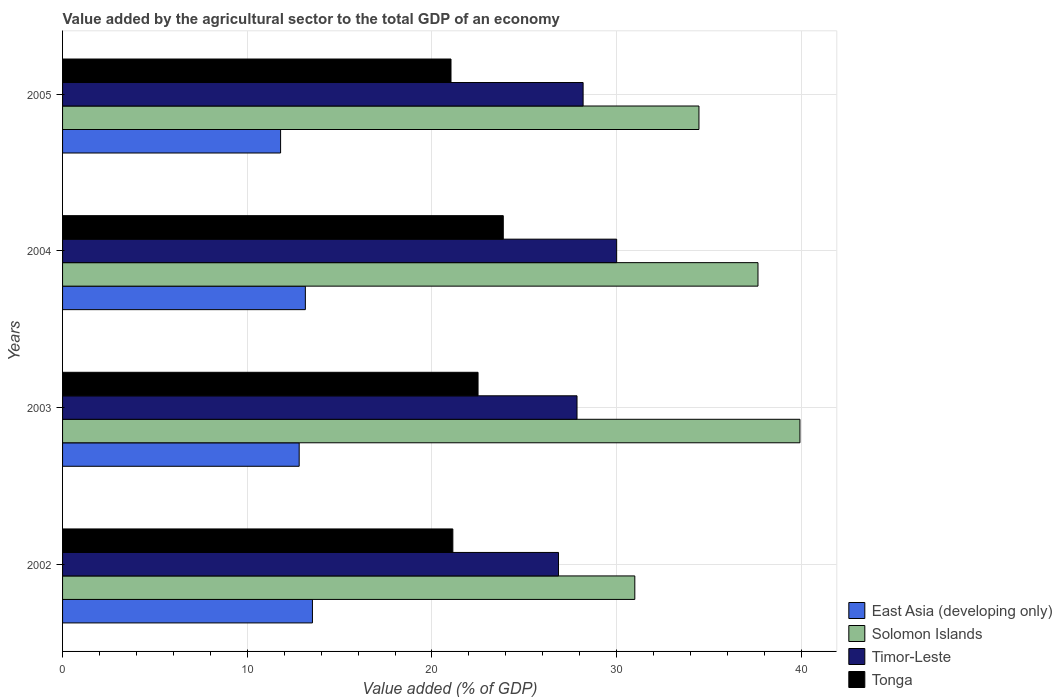How many groups of bars are there?
Make the answer very short. 4. Are the number of bars per tick equal to the number of legend labels?
Your response must be concise. Yes. Are the number of bars on each tick of the Y-axis equal?
Provide a short and direct response. Yes. How many bars are there on the 3rd tick from the bottom?
Make the answer very short. 4. What is the value added by the agricultural sector to the total GDP in Timor-Leste in 2005?
Provide a short and direct response. 28.18. Across all years, what is the maximum value added by the agricultural sector to the total GDP in Tonga?
Keep it short and to the point. 23.86. Across all years, what is the minimum value added by the agricultural sector to the total GDP in Tonga?
Your response must be concise. 21.03. In which year was the value added by the agricultural sector to the total GDP in Solomon Islands maximum?
Offer a very short reply. 2003. In which year was the value added by the agricultural sector to the total GDP in Timor-Leste minimum?
Ensure brevity in your answer.  2002. What is the total value added by the agricultural sector to the total GDP in Tonga in the graph?
Your response must be concise. 88.52. What is the difference between the value added by the agricultural sector to the total GDP in East Asia (developing only) in 2004 and that in 2005?
Your answer should be compact. 1.34. What is the difference between the value added by the agricultural sector to the total GDP in Tonga in 2005 and the value added by the agricultural sector to the total GDP in Timor-Leste in 2002?
Offer a terse response. -5.82. What is the average value added by the agricultural sector to the total GDP in Tonga per year?
Ensure brevity in your answer.  22.13. In the year 2004, what is the difference between the value added by the agricultural sector to the total GDP in Solomon Islands and value added by the agricultural sector to the total GDP in East Asia (developing only)?
Provide a succinct answer. 24.51. In how many years, is the value added by the agricultural sector to the total GDP in East Asia (developing only) greater than 18 %?
Your answer should be very brief. 0. What is the ratio of the value added by the agricultural sector to the total GDP in Tonga in 2002 to that in 2003?
Provide a short and direct response. 0.94. What is the difference between the highest and the second highest value added by the agricultural sector to the total GDP in Solomon Islands?
Make the answer very short. 2.27. What is the difference between the highest and the lowest value added by the agricultural sector to the total GDP in Timor-Leste?
Your answer should be compact. 3.15. In how many years, is the value added by the agricultural sector to the total GDP in Tonga greater than the average value added by the agricultural sector to the total GDP in Tonga taken over all years?
Provide a succinct answer. 2. What does the 4th bar from the top in 2002 represents?
Offer a very short reply. East Asia (developing only). What does the 1st bar from the bottom in 2004 represents?
Provide a succinct answer. East Asia (developing only). Is it the case that in every year, the sum of the value added by the agricultural sector to the total GDP in Tonga and value added by the agricultural sector to the total GDP in Timor-Leste is greater than the value added by the agricultural sector to the total GDP in Solomon Islands?
Offer a very short reply. Yes. How many bars are there?
Provide a succinct answer. 16. Are the values on the major ticks of X-axis written in scientific E-notation?
Keep it short and to the point. No. Does the graph contain any zero values?
Provide a succinct answer. No. Does the graph contain grids?
Provide a succinct answer. Yes. Where does the legend appear in the graph?
Provide a succinct answer. Bottom right. How many legend labels are there?
Your answer should be very brief. 4. What is the title of the graph?
Offer a terse response. Value added by the agricultural sector to the total GDP of an economy. Does "Monaco" appear as one of the legend labels in the graph?
Provide a succinct answer. No. What is the label or title of the X-axis?
Give a very brief answer. Value added (% of GDP). What is the label or title of the Y-axis?
Your answer should be compact. Years. What is the Value added (% of GDP) of East Asia (developing only) in 2002?
Keep it short and to the point. 13.53. What is the Value added (% of GDP) of Solomon Islands in 2002?
Make the answer very short. 30.98. What is the Value added (% of GDP) of Timor-Leste in 2002?
Give a very brief answer. 26.85. What is the Value added (% of GDP) of Tonga in 2002?
Make the answer very short. 21.13. What is the Value added (% of GDP) of East Asia (developing only) in 2003?
Your answer should be very brief. 12.81. What is the Value added (% of GDP) of Solomon Islands in 2003?
Your answer should be very brief. 39.92. What is the Value added (% of GDP) of Timor-Leste in 2003?
Offer a very short reply. 27.85. What is the Value added (% of GDP) in Tonga in 2003?
Give a very brief answer. 22.5. What is the Value added (% of GDP) in East Asia (developing only) in 2004?
Provide a short and direct response. 13.15. What is the Value added (% of GDP) of Solomon Islands in 2004?
Provide a succinct answer. 37.65. What is the Value added (% of GDP) of Timor-Leste in 2004?
Make the answer very short. 30. What is the Value added (% of GDP) of Tonga in 2004?
Give a very brief answer. 23.86. What is the Value added (% of GDP) in East Asia (developing only) in 2005?
Give a very brief answer. 11.8. What is the Value added (% of GDP) of Solomon Islands in 2005?
Offer a terse response. 34.46. What is the Value added (% of GDP) of Timor-Leste in 2005?
Ensure brevity in your answer.  28.18. What is the Value added (% of GDP) of Tonga in 2005?
Offer a terse response. 21.03. Across all years, what is the maximum Value added (% of GDP) of East Asia (developing only)?
Your response must be concise. 13.53. Across all years, what is the maximum Value added (% of GDP) of Solomon Islands?
Give a very brief answer. 39.92. Across all years, what is the maximum Value added (% of GDP) in Timor-Leste?
Provide a succinct answer. 30. Across all years, what is the maximum Value added (% of GDP) in Tonga?
Your answer should be very brief. 23.86. Across all years, what is the minimum Value added (% of GDP) in East Asia (developing only)?
Ensure brevity in your answer.  11.8. Across all years, what is the minimum Value added (% of GDP) of Solomon Islands?
Your answer should be very brief. 30.98. Across all years, what is the minimum Value added (% of GDP) in Timor-Leste?
Provide a succinct answer. 26.85. Across all years, what is the minimum Value added (% of GDP) in Tonga?
Offer a terse response. 21.03. What is the total Value added (% of GDP) in East Asia (developing only) in the graph?
Give a very brief answer. 51.29. What is the total Value added (% of GDP) of Solomon Islands in the graph?
Provide a succinct answer. 143.01. What is the total Value added (% of GDP) of Timor-Leste in the graph?
Your answer should be very brief. 112.89. What is the total Value added (% of GDP) of Tonga in the graph?
Your answer should be compact. 88.52. What is the difference between the Value added (% of GDP) in East Asia (developing only) in 2002 and that in 2003?
Offer a very short reply. 0.72. What is the difference between the Value added (% of GDP) in Solomon Islands in 2002 and that in 2003?
Make the answer very short. -8.94. What is the difference between the Value added (% of GDP) of Timor-Leste in 2002 and that in 2003?
Your response must be concise. -1. What is the difference between the Value added (% of GDP) in Tonga in 2002 and that in 2003?
Provide a short and direct response. -1.36. What is the difference between the Value added (% of GDP) in East Asia (developing only) in 2002 and that in 2004?
Your response must be concise. 0.38. What is the difference between the Value added (% of GDP) of Solomon Islands in 2002 and that in 2004?
Your answer should be compact. -6.67. What is the difference between the Value added (% of GDP) in Timor-Leste in 2002 and that in 2004?
Your response must be concise. -3.15. What is the difference between the Value added (% of GDP) of Tonga in 2002 and that in 2004?
Give a very brief answer. -2.73. What is the difference between the Value added (% of GDP) in East Asia (developing only) in 2002 and that in 2005?
Your answer should be very brief. 1.72. What is the difference between the Value added (% of GDP) of Solomon Islands in 2002 and that in 2005?
Provide a short and direct response. -3.47. What is the difference between the Value added (% of GDP) in Timor-Leste in 2002 and that in 2005?
Give a very brief answer. -1.33. What is the difference between the Value added (% of GDP) in Tonga in 2002 and that in 2005?
Ensure brevity in your answer.  0.1. What is the difference between the Value added (% of GDP) in East Asia (developing only) in 2003 and that in 2004?
Keep it short and to the point. -0.33. What is the difference between the Value added (% of GDP) of Solomon Islands in 2003 and that in 2004?
Your answer should be very brief. 2.27. What is the difference between the Value added (% of GDP) of Timor-Leste in 2003 and that in 2004?
Provide a short and direct response. -2.15. What is the difference between the Value added (% of GDP) of Tonga in 2003 and that in 2004?
Give a very brief answer. -1.37. What is the difference between the Value added (% of GDP) of Solomon Islands in 2003 and that in 2005?
Provide a succinct answer. 5.47. What is the difference between the Value added (% of GDP) in Timor-Leste in 2003 and that in 2005?
Your response must be concise. -0.33. What is the difference between the Value added (% of GDP) in Tonga in 2003 and that in 2005?
Offer a terse response. 1.46. What is the difference between the Value added (% of GDP) in East Asia (developing only) in 2004 and that in 2005?
Provide a short and direct response. 1.34. What is the difference between the Value added (% of GDP) of Solomon Islands in 2004 and that in 2005?
Your answer should be very brief. 3.2. What is the difference between the Value added (% of GDP) of Timor-Leste in 2004 and that in 2005?
Give a very brief answer. 1.82. What is the difference between the Value added (% of GDP) in Tonga in 2004 and that in 2005?
Keep it short and to the point. 2.83. What is the difference between the Value added (% of GDP) of East Asia (developing only) in 2002 and the Value added (% of GDP) of Solomon Islands in 2003?
Give a very brief answer. -26.39. What is the difference between the Value added (% of GDP) in East Asia (developing only) in 2002 and the Value added (% of GDP) in Timor-Leste in 2003?
Provide a short and direct response. -14.32. What is the difference between the Value added (% of GDP) in East Asia (developing only) in 2002 and the Value added (% of GDP) in Tonga in 2003?
Keep it short and to the point. -8.97. What is the difference between the Value added (% of GDP) in Solomon Islands in 2002 and the Value added (% of GDP) in Timor-Leste in 2003?
Your answer should be compact. 3.13. What is the difference between the Value added (% of GDP) in Solomon Islands in 2002 and the Value added (% of GDP) in Tonga in 2003?
Ensure brevity in your answer.  8.49. What is the difference between the Value added (% of GDP) in Timor-Leste in 2002 and the Value added (% of GDP) in Tonga in 2003?
Ensure brevity in your answer.  4.36. What is the difference between the Value added (% of GDP) of East Asia (developing only) in 2002 and the Value added (% of GDP) of Solomon Islands in 2004?
Offer a terse response. -24.12. What is the difference between the Value added (% of GDP) of East Asia (developing only) in 2002 and the Value added (% of GDP) of Timor-Leste in 2004?
Ensure brevity in your answer.  -16.47. What is the difference between the Value added (% of GDP) in East Asia (developing only) in 2002 and the Value added (% of GDP) in Tonga in 2004?
Your answer should be compact. -10.33. What is the difference between the Value added (% of GDP) in Solomon Islands in 2002 and the Value added (% of GDP) in Timor-Leste in 2004?
Keep it short and to the point. 0.98. What is the difference between the Value added (% of GDP) of Solomon Islands in 2002 and the Value added (% of GDP) of Tonga in 2004?
Your answer should be very brief. 7.12. What is the difference between the Value added (% of GDP) of Timor-Leste in 2002 and the Value added (% of GDP) of Tonga in 2004?
Keep it short and to the point. 2.99. What is the difference between the Value added (% of GDP) of East Asia (developing only) in 2002 and the Value added (% of GDP) of Solomon Islands in 2005?
Your answer should be very brief. -20.93. What is the difference between the Value added (% of GDP) in East Asia (developing only) in 2002 and the Value added (% of GDP) in Timor-Leste in 2005?
Offer a very short reply. -14.65. What is the difference between the Value added (% of GDP) of East Asia (developing only) in 2002 and the Value added (% of GDP) of Tonga in 2005?
Your response must be concise. -7.5. What is the difference between the Value added (% of GDP) in Solomon Islands in 2002 and the Value added (% of GDP) in Timor-Leste in 2005?
Make the answer very short. 2.8. What is the difference between the Value added (% of GDP) of Solomon Islands in 2002 and the Value added (% of GDP) of Tonga in 2005?
Provide a succinct answer. 9.95. What is the difference between the Value added (% of GDP) of Timor-Leste in 2002 and the Value added (% of GDP) of Tonga in 2005?
Your answer should be very brief. 5.82. What is the difference between the Value added (% of GDP) of East Asia (developing only) in 2003 and the Value added (% of GDP) of Solomon Islands in 2004?
Your answer should be compact. -24.84. What is the difference between the Value added (% of GDP) of East Asia (developing only) in 2003 and the Value added (% of GDP) of Timor-Leste in 2004?
Give a very brief answer. -17.19. What is the difference between the Value added (% of GDP) in East Asia (developing only) in 2003 and the Value added (% of GDP) in Tonga in 2004?
Ensure brevity in your answer.  -11.05. What is the difference between the Value added (% of GDP) of Solomon Islands in 2003 and the Value added (% of GDP) of Timor-Leste in 2004?
Ensure brevity in your answer.  9.92. What is the difference between the Value added (% of GDP) in Solomon Islands in 2003 and the Value added (% of GDP) in Tonga in 2004?
Provide a succinct answer. 16.06. What is the difference between the Value added (% of GDP) of Timor-Leste in 2003 and the Value added (% of GDP) of Tonga in 2004?
Make the answer very short. 3.99. What is the difference between the Value added (% of GDP) of East Asia (developing only) in 2003 and the Value added (% of GDP) of Solomon Islands in 2005?
Make the answer very short. -21.64. What is the difference between the Value added (% of GDP) in East Asia (developing only) in 2003 and the Value added (% of GDP) in Timor-Leste in 2005?
Your response must be concise. -15.37. What is the difference between the Value added (% of GDP) in East Asia (developing only) in 2003 and the Value added (% of GDP) in Tonga in 2005?
Ensure brevity in your answer.  -8.22. What is the difference between the Value added (% of GDP) of Solomon Islands in 2003 and the Value added (% of GDP) of Timor-Leste in 2005?
Provide a succinct answer. 11.74. What is the difference between the Value added (% of GDP) of Solomon Islands in 2003 and the Value added (% of GDP) of Tonga in 2005?
Provide a succinct answer. 18.89. What is the difference between the Value added (% of GDP) in Timor-Leste in 2003 and the Value added (% of GDP) in Tonga in 2005?
Keep it short and to the point. 6.82. What is the difference between the Value added (% of GDP) of East Asia (developing only) in 2004 and the Value added (% of GDP) of Solomon Islands in 2005?
Give a very brief answer. -21.31. What is the difference between the Value added (% of GDP) in East Asia (developing only) in 2004 and the Value added (% of GDP) in Timor-Leste in 2005?
Ensure brevity in your answer.  -15.04. What is the difference between the Value added (% of GDP) in East Asia (developing only) in 2004 and the Value added (% of GDP) in Tonga in 2005?
Your answer should be compact. -7.89. What is the difference between the Value added (% of GDP) of Solomon Islands in 2004 and the Value added (% of GDP) of Timor-Leste in 2005?
Your answer should be compact. 9.47. What is the difference between the Value added (% of GDP) of Solomon Islands in 2004 and the Value added (% of GDP) of Tonga in 2005?
Give a very brief answer. 16.62. What is the difference between the Value added (% of GDP) in Timor-Leste in 2004 and the Value added (% of GDP) in Tonga in 2005?
Offer a very short reply. 8.97. What is the average Value added (% of GDP) in East Asia (developing only) per year?
Provide a short and direct response. 12.82. What is the average Value added (% of GDP) of Solomon Islands per year?
Provide a succinct answer. 35.75. What is the average Value added (% of GDP) in Timor-Leste per year?
Provide a succinct answer. 28.22. What is the average Value added (% of GDP) of Tonga per year?
Your answer should be compact. 22.13. In the year 2002, what is the difference between the Value added (% of GDP) of East Asia (developing only) and Value added (% of GDP) of Solomon Islands?
Your answer should be very brief. -17.45. In the year 2002, what is the difference between the Value added (% of GDP) in East Asia (developing only) and Value added (% of GDP) in Timor-Leste?
Your response must be concise. -13.32. In the year 2002, what is the difference between the Value added (% of GDP) of East Asia (developing only) and Value added (% of GDP) of Tonga?
Offer a terse response. -7.6. In the year 2002, what is the difference between the Value added (% of GDP) in Solomon Islands and Value added (% of GDP) in Timor-Leste?
Offer a terse response. 4.13. In the year 2002, what is the difference between the Value added (% of GDP) of Solomon Islands and Value added (% of GDP) of Tonga?
Keep it short and to the point. 9.85. In the year 2002, what is the difference between the Value added (% of GDP) of Timor-Leste and Value added (% of GDP) of Tonga?
Provide a succinct answer. 5.72. In the year 2003, what is the difference between the Value added (% of GDP) of East Asia (developing only) and Value added (% of GDP) of Solomon Islands?
Provide a short and direct response. -27.11. In the year 2003, what is the difference between the Value added (% of GDP) in East Asia (developing only) and Value added (% of GDP) in Timor-Leste?
Provide a succinct answer. -15.04. In the year 2003, what is the difference between the Value added (% of GDP) in East Asia (developing only) and Value added (% of GDP) in Tonga?
Your answer should be compact. -9.68. In the year 2003, what is the difference between the Value added (% of GDP) of Solomon Islands and Value added (% of GDP) of Timor-Leste?
Provide a succinct answer. 12.07. In the year 2003, what is the difference between the Value added (% of GDP) of Solomon Islands and Value added (% of GDP) of Tonga?
Keep it short and to the point. 17.43. In the year 2003, what is the difference between the Value added (% of GDP) of Timor-Leste and Value added (% of GDP) of Tonga?
Provide a succinct answer. 5.36. In the year 2004, what is the difference between the Value added (% of GDP) of East Asia (developing only) and Value added (% of GDP) of Solomon Islands?
Provide a short and direct response. -24.51. In the year 2004, what is the difference between the Value added (% of GDP) of East Asia (developing only) and Value added (% of GDP) of Timor-Leste?
Ensure brevity in your answer.  -16.85. In the year 2004, what is the difference between the Value added (% of GDP) of East Asia (developing only) and Value added (% of GDP) of Tonga?
Make the answer very short. -10.72. In the year 2004, what is the difference between the Value added (% of GDP) in Solomon Islands and Value added (% of GDP) in Timor-Leste?
Your answer should be very brief. 7.65. In the year 2004, what is the difference between the Value added (% of GDP) in Solomon Islands and Value added (% of GDP) in Tonga?
Provide a short and direct response. 13.79. In the year 2004, what is the difference between the Value added (% of GDP) of Timor-Leste and Value added (% of GDP) of Tonga?
Offer a terse response. 6.14. In the year 2005, what is the difference between the Value added (% of GDP) in East Asia (developing only) and Value added (% of GDP) in Solomon Islands?
Provide a short and direct response. -22.65. In the year 2005, what is the difference between the Value added (% of GDP) of East Asia (developing only) and Value added (% of GDP) of Timor-Leste?
Ensure brevity in your answer.  -16.38. In the year 2005, what is the difference between the Value added (% of GDP) of East Asia (developing only) and Value added (% of GDP) of Tonga?
Offer a very short reply. -9.23. In the year 2005, what is the difference between the Value added (% of GDP) in Solomon Islands and Value added (% of GDP) in Timor-Leste?
Ensure brevity in your answer.  6.27. In the year 2005, what is the difference between the Value added (% of GDP) of Solomon Islands and Value added (% of GDP) of Tonga?
Provide a succinct answer. 13.42. In the year 2005, what is the difference between the Value added (% of GDP) of Timor-Leste and Value added (% of GDP) of Tonga?
Provide a short and direct response. 7.15. What is the ratio of the Value added (% of GDP) of East Asia (developing only) in 2002 to that in 2003?
Your answer should be very brief. 1.06. What is the ratio of the Value added (% of GDP) in Solomon Islands in 2002 to that in 2003?
Offer a very short reply. 0.78. What is the ratio of the Value added (% of GDP) in Tonga in 2002 to that in 2003?
Provide a short and direct response. 0.94. What is the ratio of the Value added (% of GDP) of East Asia (developing only) in 2002 to that in 2004?
Your answer should be very brief. 1.03. What is the ratio of the Value added (% of GDP) of Solomon Islands in 2002 to that in 2004?
Your answer should be compact. 0.82. What is the ratio of the Value added (% of GDP) of Timor-Leste in 2002 to that in 2004?
Provide a short and direct response. 0.9. What is the ratio of the Value added (% of GDP) in Tonga in 2002 to that in 2004?
Your response must be concise. 0.89. What is the ratio of the Value added (% of GDP) in East Asia (developing only) in 2002 to that in 2005?
Give a very brief answer. 1.15. What is the ratio of the Value added (% of GDP) in Solomon Islands in 2002 to that in 2005?
Provide a succinct answer. 0.9. What is the ratio of the Value added (% of GDP) in Timor-Leste in 2002 to that in 2005?
Give a very brief answer. 0.95. What is the ratio of the Value added (% of GDP) of Tonga in 2002 to that in 2005?
Offer a very short reply. 1. What is the ratio of the Value added (% of GDP) in East Asia (developing only) in 2003 to that in 2004?
Ensure brevity in your answer.  0.97. What is the ratio of the Value added (% of GDP) of Solomon Islands in 2003 to that in 2004?
Your answer should be very brief. 1.06. What is the ratio of the Value added (% of GDP) of Timor-Leste in 2003 to that in 2004?
Keep it short and to the point. 0.93. What is the ratio of the Value added (% of GDP) of Tonga in 2003 to that in 2004?
Your answer should be compact. 0.94. What is the ratio of the Value added (% of GDP) in East Asia (developing only) in 2003 to that in 2005?
Provide a succinct answer. 1.09. What is the ratio of the Value added (% of GDP) of Solomon Islands in 2003 to that in 2005?
Provide a short and direct response. 1.16. What is the ratio of the Value added (% of GDP) of Timor-Leste in 2003 to that in 2005?
Give a very brief answer. 0.99. What is the ratio of the Value added (% of GDP) in Tonga in 2003 to that in 2005?
Your answer should be very brief. 1.07. What is the ratio of the Value added (% of GDP) in East Asia (developing only) in 2004 to that in 2005?
Provide a succinct answer. 1.11. What is the ratio of the Value added (% of GDP) of Solomon Islands in 2004 to that in 2005?
Offer a very short reply. 1.09. What is the ratio of the Value added (% of GDP) of Timor-Leste in 2004 to that in 2005?
Ensure brevity in your answer.  1.06. What is the ratio of the Value added (% of GDP) of Tonga in 2004 to that in 2005?
Ensure brevity in your answer.  1.13. What is the difference between the highest and the second highest Value added (% of GDP) in East Asia (developing only)?
Make the answer very short. 0.38. What is the difference between the highest and the second highest Value added (% of GDP) of Solomon Islands?
Offer a terse response. 2.27. What is the difference between the highest and the second highest Value added (% of GDP) in Timor-Leste?
Your answer should be compact. 1.82. What is the difference between the highest and the second highest Value added (% of GDP) in Tonga?
Your answer should be very brief. 1.37. What is the difference between the highest and the lowest Value added (% of GDP) of East Asia (developing only)?
Keep it short and to the point. 1.72. What is the difference between the highest and the lowest Value added (% of GDP) in Solomon Islands?
Keep it short and to the point. 8.94. What is the difference between the highest and the lowest Value added (% of GDP) of Timor-Leste?
Your answer should be compact. 3.15. What is the difference between the highest and the lowest Value added (% of GDP) in Tonga?
Offer a terse response. 2.83. 